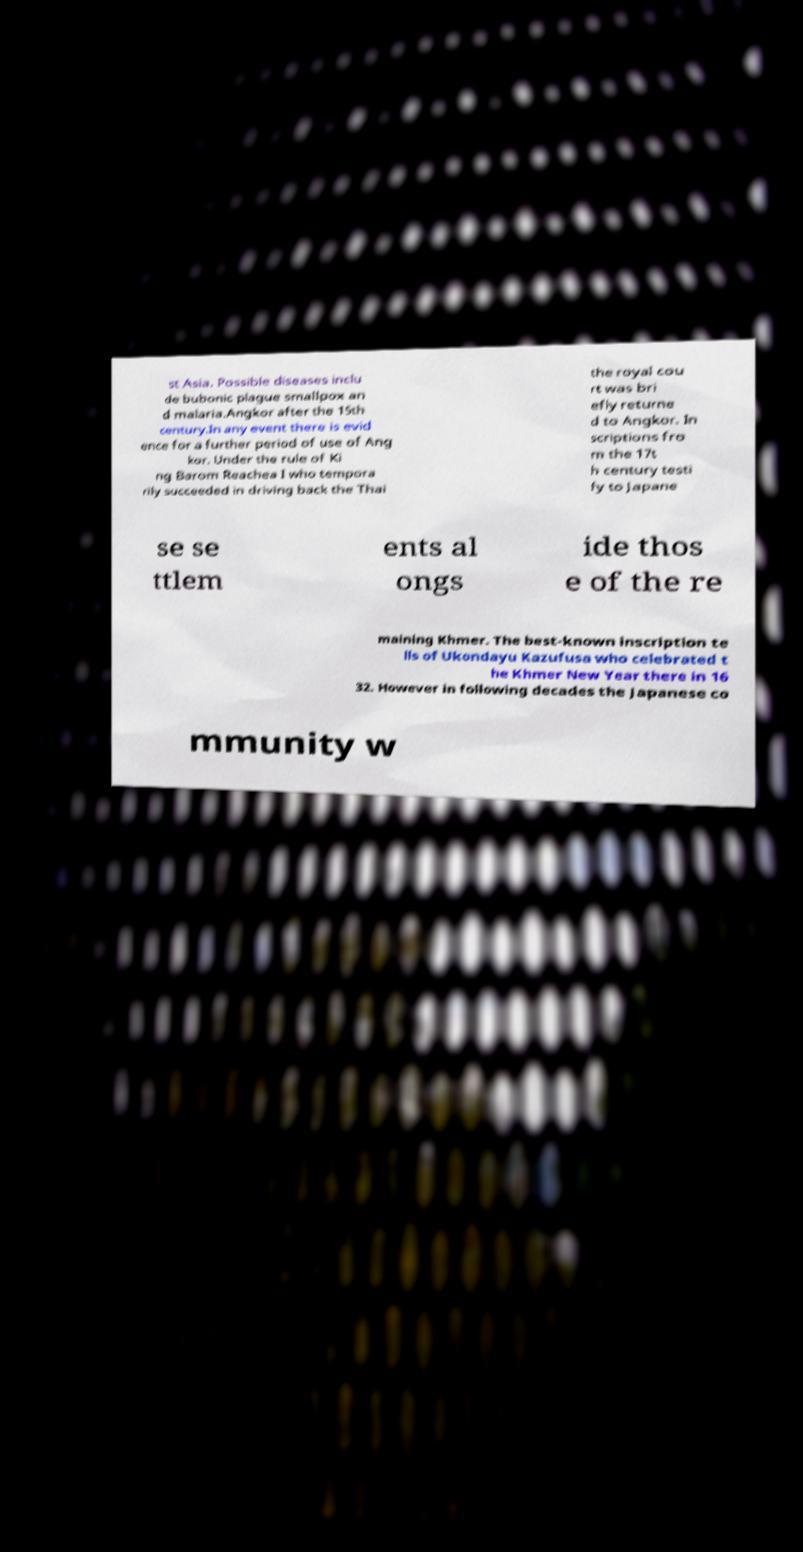For documentation purposes, I need the text within this image transcribed. Could you provide that? st Asia. Possible diseases inclu de bubonic plague smallpox an d malaria.Angkor after the 15th century.In any event there is evid ence for a further period of use of Ang kor. Under the rule of Ki ng Barom Reachea I who tempora rily succeeded in driving back the Thai the royal cou rt was bri efly returne d to Angkor. In scriptions fro m the 17t h century testi fy to Japane se se ttlem ents al ongs ide thos e of the re maining Khmer. The best-known inscription te lls of Ukondayu Kazufusa who celebrated t he Khmer New Year there in 16 32. However in following decades the Japanese co mmunity w 